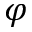Convert formula to latex. <formula><loc_0><loc_0><loc_500><loc_500>\varphi</formula> 